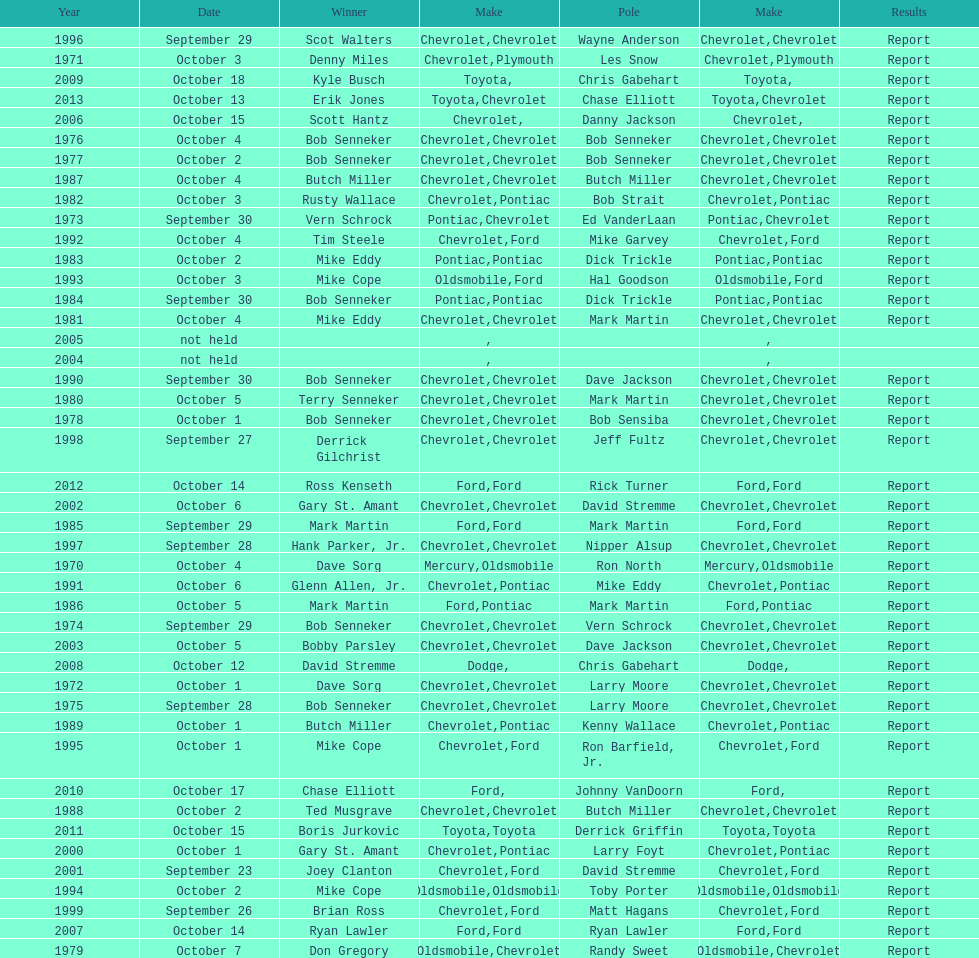Which brand was utilized the least? Mercury. 